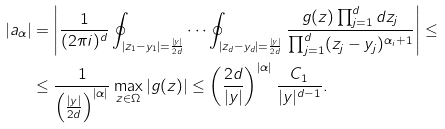<formula> <loc_0><loc_0><loc_500><loc_500>| a _ { \alpha } | & = \left | \frac { 1 } { ( 2 \pi i ) ^ { d } } \oint _ { | z _ { 1 } - y _ { 1 } | = \frac { | y | } { 2 d } } \cdots \oint _ { | z _ { d } - y _ { d } | = \frac { | y | } { 2 d } } \frac { g ( z ) \prod _ { j = 1 } ^ { d } d z _ { j } } { \prod _ { j = 1 } ^ { d } ( z _ { j } - y _ { j } ) ^ { \alpha _ { i } + 1 } } \right | \leq \\ & \leq \frac { 1 } { \left ( \frac { | y | } { 2 d } \right ) ^ { | \alpha | } } \max _ { z \in \Omega } | g ( z ) | \leq \left ( \frac { 2 d } { | y | } \right ) ^ { | \alpha | } \frac { C _ { 1 } } { | y | ^ { d - 1 } } .</formula> 